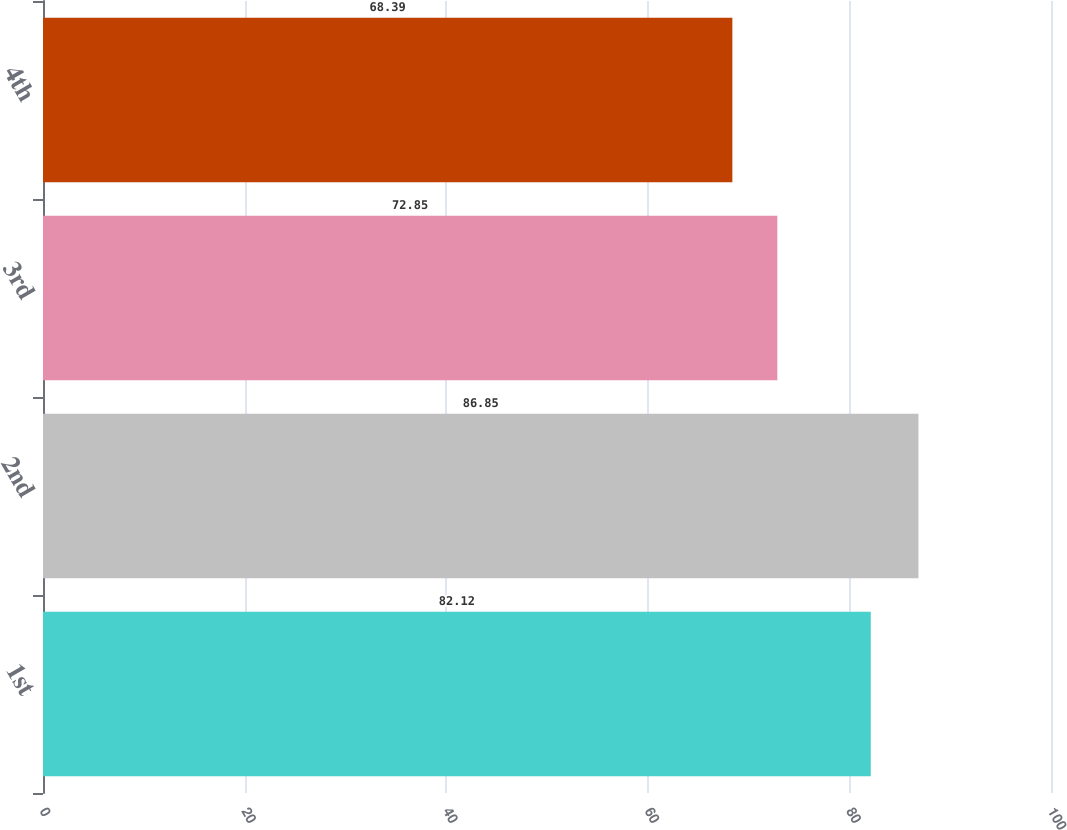<chart> <loc_0><loc_0><loc_500><loc_500><bar_chart><fcel>1st<fcel>2nd<fcel>3rd<fcel>4th<nl><fcel>82.12<fcel>86.85<fcel>72.85<fcel>68.39<nl></chart> 